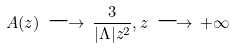Convert formula to latex. <formula><loc_0><loc_0><loc_500><loc_500>A ( z ) \, \longrightarrow \, \frac { 3 } { | { \Lambda } | z ^ { 2 } } , z \, \longrightarrow \, + \infty</formula> 